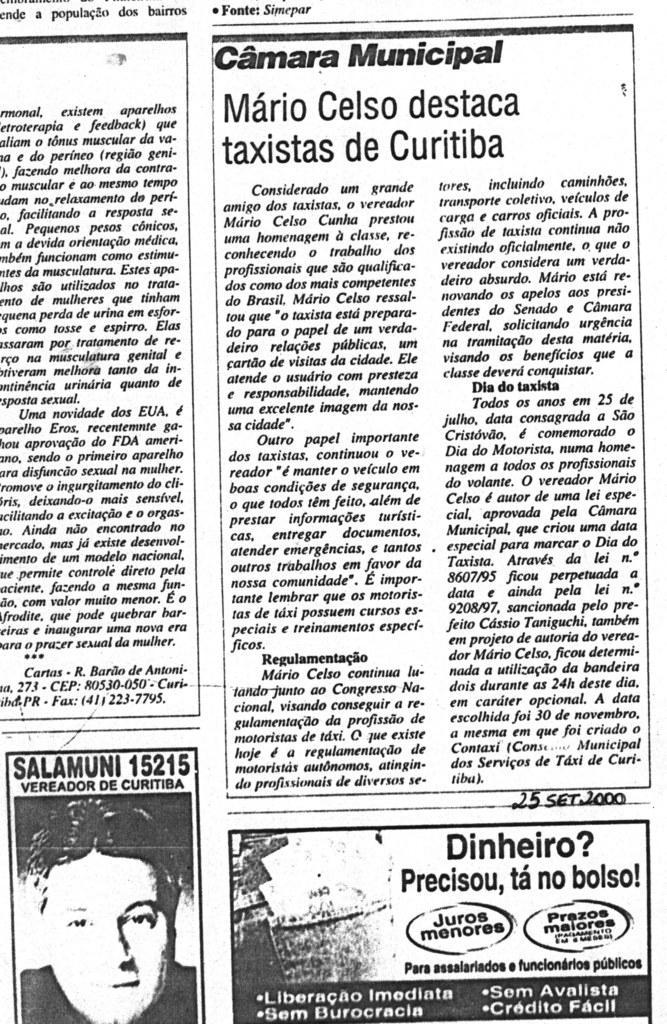How would you summarize this image in a sentence or two? In this picture we can see the newspaper poster in the front. On the bottom side there is a photo of the man face and some quotes. 